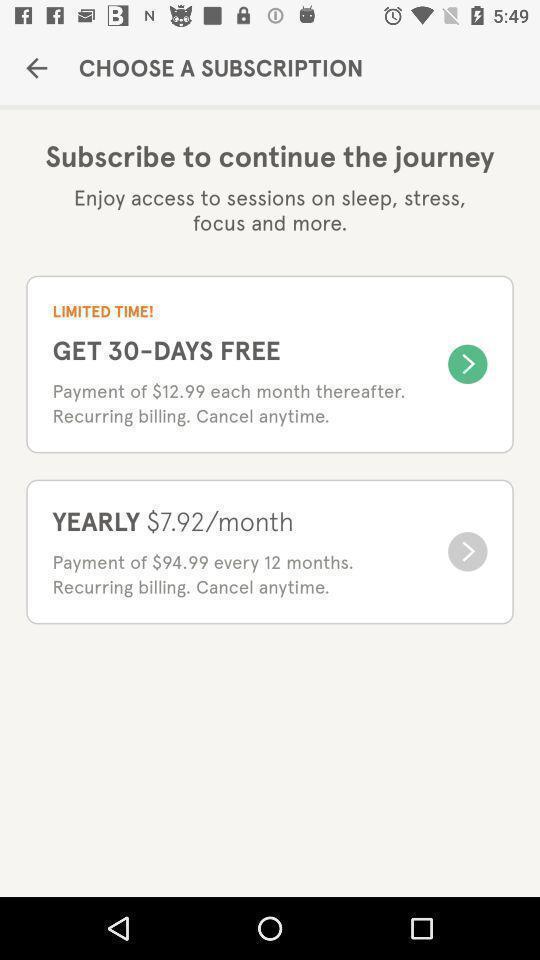Describe this image in words. Page displaying various subscription options. 